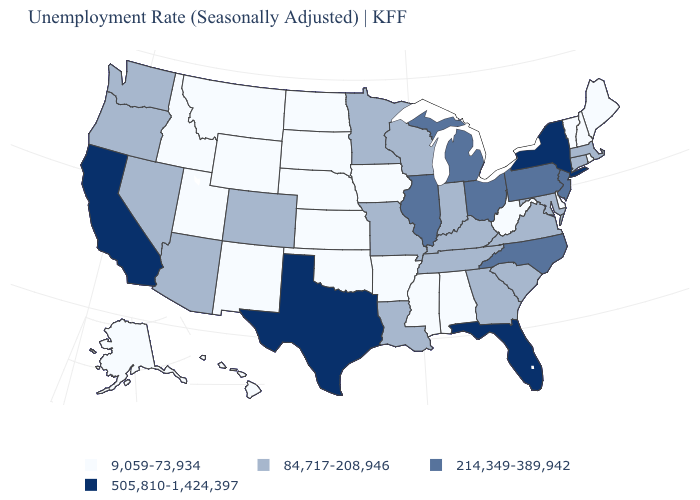Name the states that have a value in the range 9,059-73,934?
Concise answer only. Alabama, Alaska, Arkansas, Delaware, Hawaii, Idaho, Iowa, Kansas, Maine, Mississippi, Montana, Nebraska, New Hampshire, New Mexico, North Dakota, Oklahoma, Rhode Island, South Dakota, Utah, Vermont, West Virginia, Wyoming. Name the states that have a value in the range 214,349-389,942?
Keep it brief. Illinois, Michigan, New Jersey, North Carolina, Ohio, Pennsylvania. Is the legend a continuous bar?
Be succinct. No. Name the states that have a value in the range 84,717-208,946?
Concise answer only. Arizona, Colorado, Connecticut, Georgia, Indiana, Kentucky, Louisiana, Maryland, Massachusetts, Minnesota, Missouri, Nevada, Oregon, South Carolina, Tennessee, Virginia, Washington, Wisconsin. Name the states that have a value in the range 84,717-208,946?
Quick response, please. Arizona, Colorado, Connecticut, Georgia, Indiana, Kentucky, Louisiana, Maryland, Massachusetts, Minnesota, Missouri, Nevada, Oregon, South Carolina, Tennessee, Virginia, Washington, Wisconsin. Does Minnesota have a lower value than Florida?
Short answer required. Yes. Among the states that border West Virginia , does Ohio have the highest value?
Short answer required. Yes. Which states hav the highest value in the South?
Write a very short answer. Florida, Texas. Name the states that have a value in the range 505,810-1,424,397?
Keep it brief. California, Florida, New York, Texas. Among the states that border Arizona , which have the highest value?
Keep it brief. California. What is the highest value in the USA?
Write a very short answer. 505,810-1,424,397. Among the states that border Nebraska , which have the lowest value?
Write a very short answer. Iowa, Kansas, South Dakota, Wyoming. What is the highest value in the MidWest ?
Quick response, please. 214,349-389,942. Does Iowa have the highest value in the USA?
Answer briefly. No. Name the states that have a value in the range 505,810-1,424,397?
Write a very short answer. California, Florida, New York, Texas. 